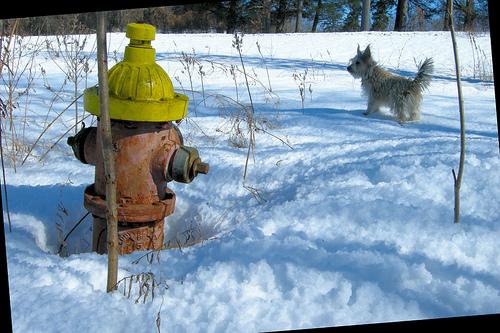Why is this juxtaposition humorous?
Write a very short answer. Dogs pee on fire hydrants. What season is this?
Write a very short answer. Winter. What is the dog looking at?
Answer briefly. Trees. 